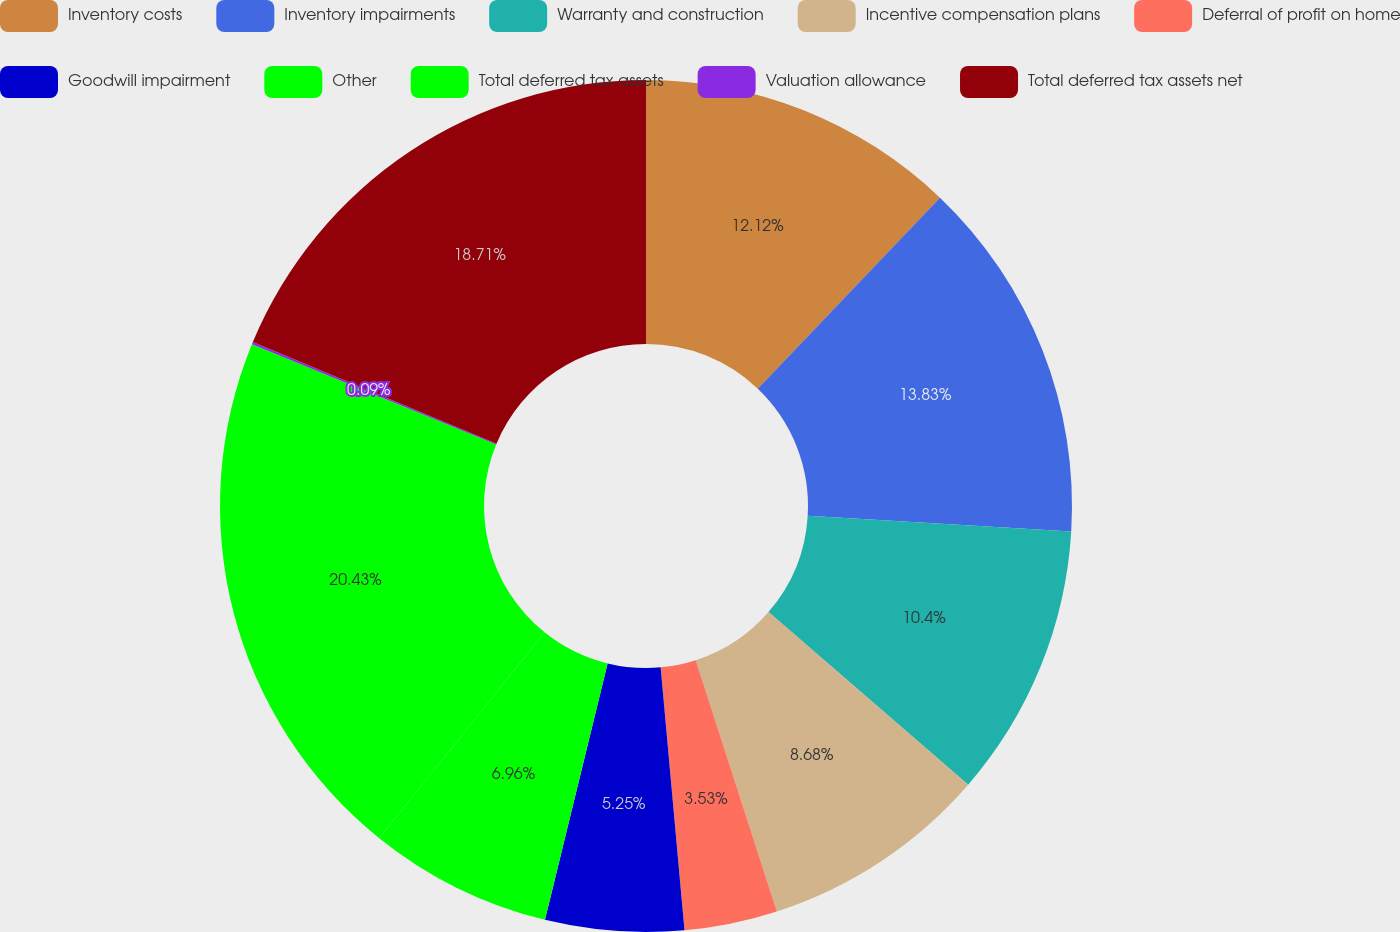Convert chart. <chart><loc_0><loc_0><loc_500><loc_500><pie_chart><fcel>Inventory costs<fcel>Inventory impairments<fcel>Warranty and construction<fcel>Incentive compensation plans<fcel>Deferral of profit on home<fcel>Goodwill impairment<fcel>Other<fcel>Total deferred tax assets<fcel>Valuation allowance<fcel>Total deferred tax assets net<nl><fcel>12.12%<fcel>13.83%<fcel>10.4%<fcel>8.68%<fcel>3.53%<fcel>5.25%<fcel>6.96%<fcel>20.43%<fcel>0.09%<fcel>18.71%<nl></chart> 